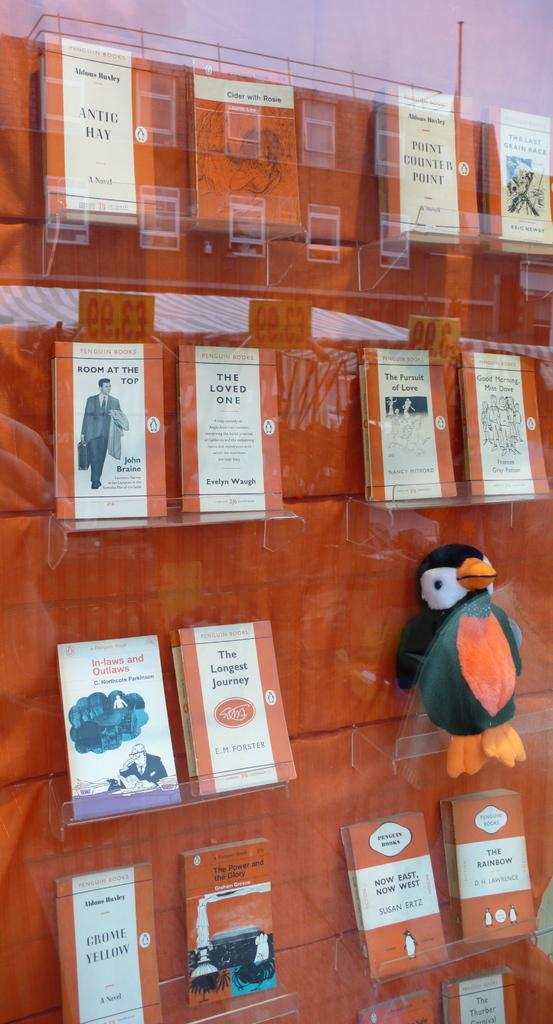<image>
Relay a brief, clear account of the picture shown. Multiple books from the Penguin Books company sit on display. 